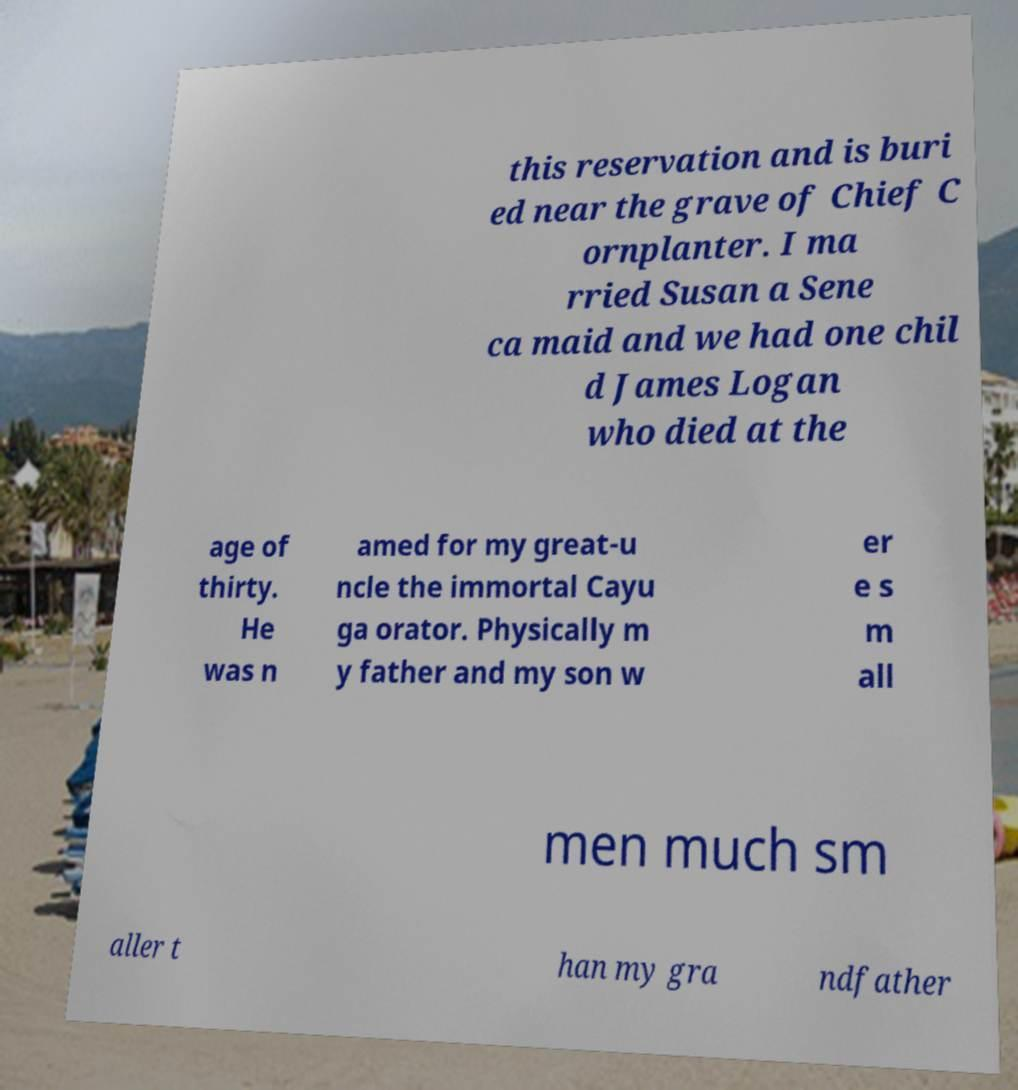Please read and relay the text visible in this image. What does it say? this reservation and is buri ed near the grave of Chief C ornplanter. I ma rried Susan a Sene ca maid and we had one chil d James Logan who died at the age of thirty. He was n amed for my great-u ncle the immortal Cayu ga orator. Physically m y father and my son w er e s m all men much sm aller t han my gra ndfather 